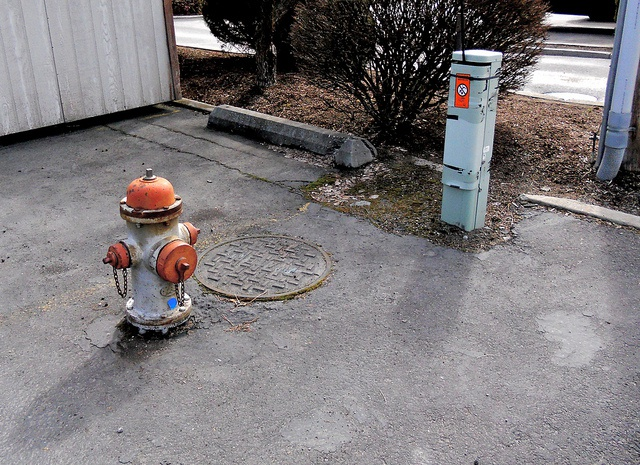Describe the objects in this image and their specific colors. I can see a fire hydrant in darkgray, gray, black, and maroon tones in this image. 